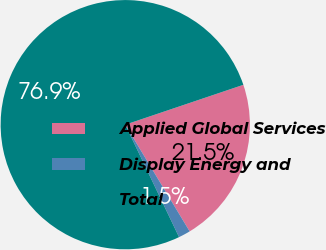Convert chart. <chart><loc_0><loc_0><loc_500><loc_500><pie_chart><fcel>Applied Global Services<fcel>Display Energy and<fcel>Total<nl><fcel>21.54%<fcel>1.54%<fcel>76.92%<nl></chart> 